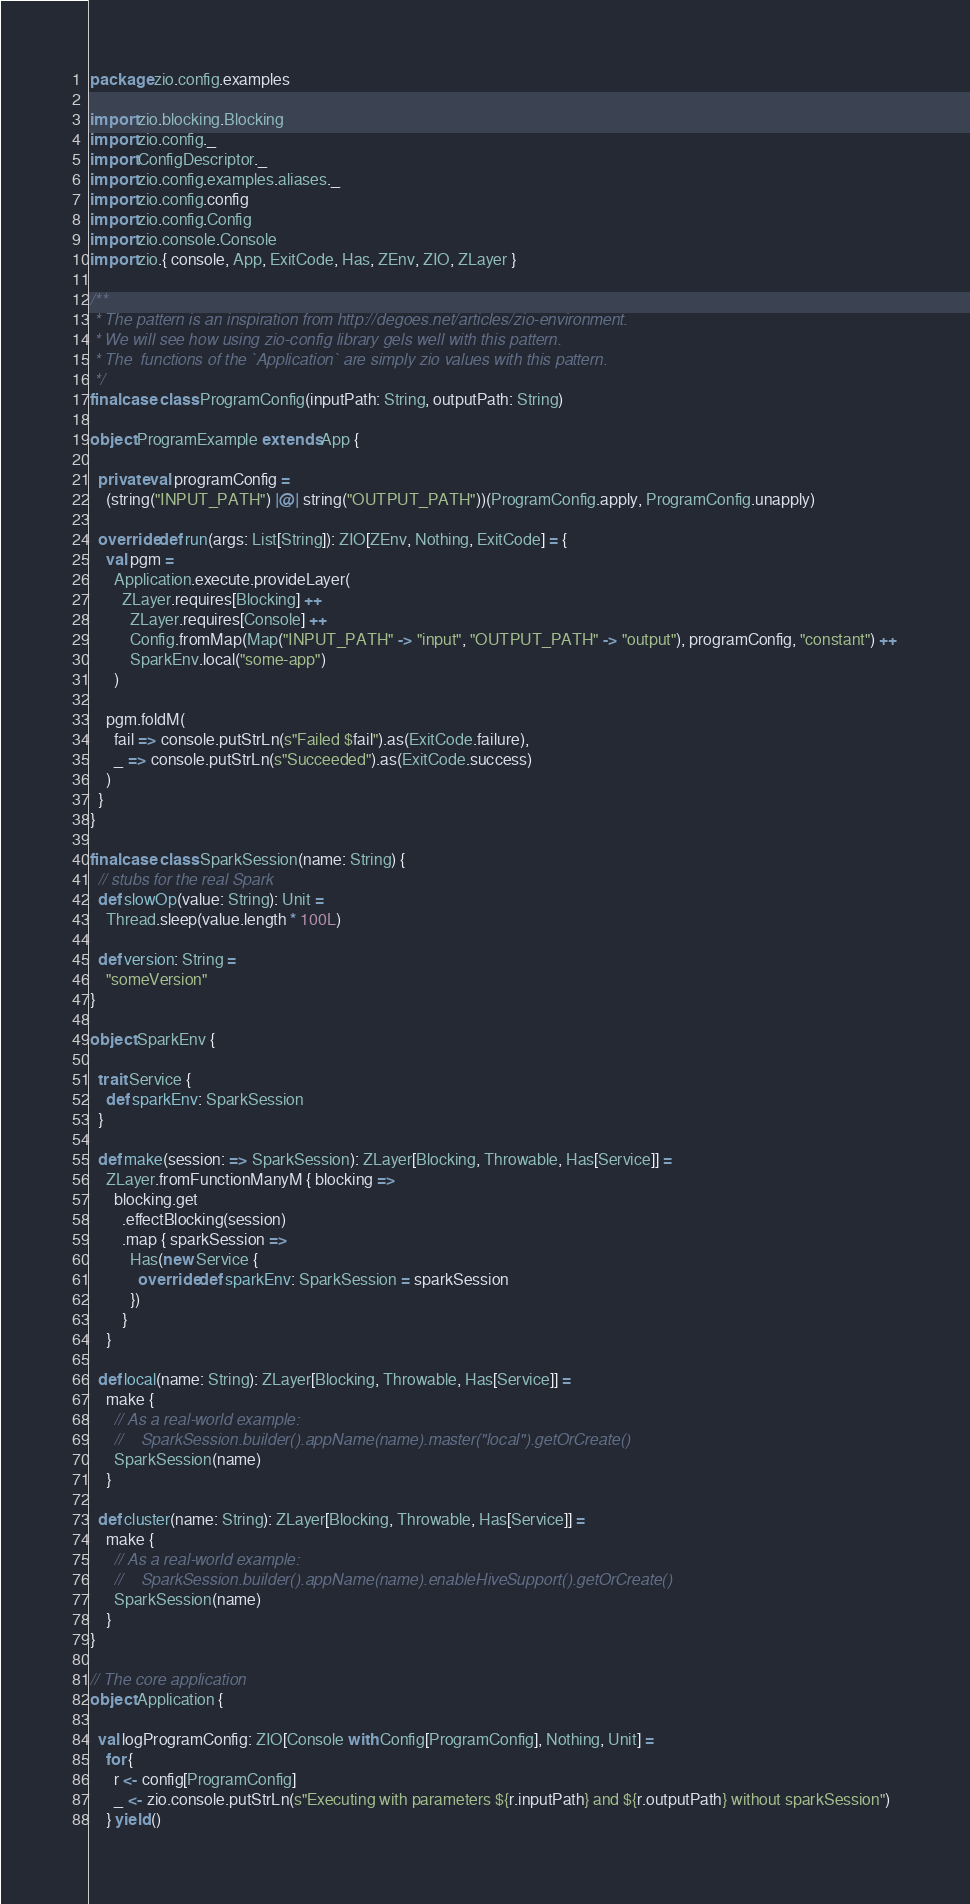<code> <loc_0><loc_0><loc_500><loc_500><_Scala_>package zio.config.examples

import zio.blocking.Blocking
import zio.config._
import ConfigDescriptor._
import zio.config.examples.aliases._
import zio.config.config
import zio.config.Config
import zio.console.Console
import zio.{ console, App, ExitCode, Has, ZEnv, ZIO, ZLayer }

/**
 * The pattern is an inspiration from http://degoes.net/articles/zio-environment.
 * We will see how using zio-config library gels well with this pattern.
 * The  functions of the `Application` are simply zio values with this pattern.
 */
final case class ProgramConfig(inputPath: String, outputPath: String)

object ProgramExample extends App {

  private val programConfig =
    (string("INPUT_PATH") |@| string("OUTPUT_PATH"))(ProgramConfig.apply, ProgramConfig.unapply)

  override def run(args: List[String]): ZIO[ZEnv, Nothing, ExitCode] = {
    val pgm =
      Application.execute.provideLayer(
        ZLayer.requires[Blocking] ++
          ZLayer.requires[Console] ++
          Config.fromMap(Map("INPUT_PATH" -> "input", "OUTPUT_PATH" -> "output"), programConfig, "constant") ++
          SparkEnv.local("some-app")
      )

    pgm.foldM(
      fail => console.putStrLn(s"Failed $fail").as(ExitCode.failure),
      _ => console.putStrLn(s"Succeeded").as(ExitCode.success)
    )
  }
}

final case class SparkSession(name: String) {
  // stubs for the real Spark
  def slowOp(value: String): Unit =
    Thread.sleep(value.length * 100L)

  def version: String =
    "someVersion"
}

object SparkEnv {

  trait Service {
    def sparkEnv: SparkSession
  }

  def make(session: => SparkSession): ZLayer[Blocking, Throwable, Has[Service]] =
    ZLayer.fromFunctionManyM { blocking =>
      blocking.get
        .effectBlocking(session)
        .map { sparkSession =>
          Has(new Service {
            override def sparkEnv: SparkSession = sparkSession
          })
        }
    }

  def local(name: String): ZLayer[Blocking, Throwable, Has[Service]] =
    make {
      // As a real-world example:
      //    SparkSession.builder().appName(name).master("local").getOrCreate()
      SparkSession(name)
    }

  def cluster(name: String): ZLayer[Blocking, Throwable, Has[Service]] =
    make {
      // As a real-world example:
      //    SparkSession.builder().appName(name).enableHiveSupport().getOrCreate()
      SparkSession(name)
    }
}

// The core application
object Application {

  val logProgramConfig: ZIO[Console with Config[ProgramConfig], Nothing, Unit] =
    for {
      r <- config[ProgramConfig]
      _ <- zio.console.putStrLn(s"Executing with parameters ${r.inputPath} and ${r.outputPath} without sparkSession")
    } yield ()
</code> 